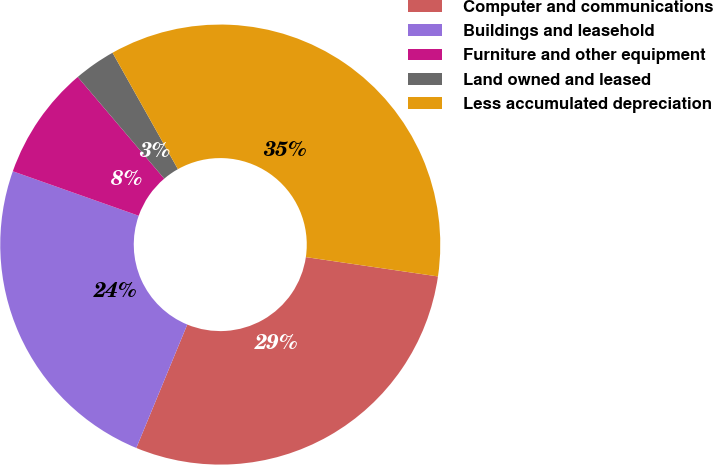<chart> <loc_0><loc_0><loc_500><loc_500><pie_chart><fcel>Computer and communications<fcel>Buildings and leasehold<fcel>Furniture and other equipment<fcel>Land owned and leased<fcel>Less accumulated depreciation<nl><fcel>28.92%<fcel>24.18%<fcel>8.38%<fcel>3.07%<fcel>35.46%<nl></chart> 